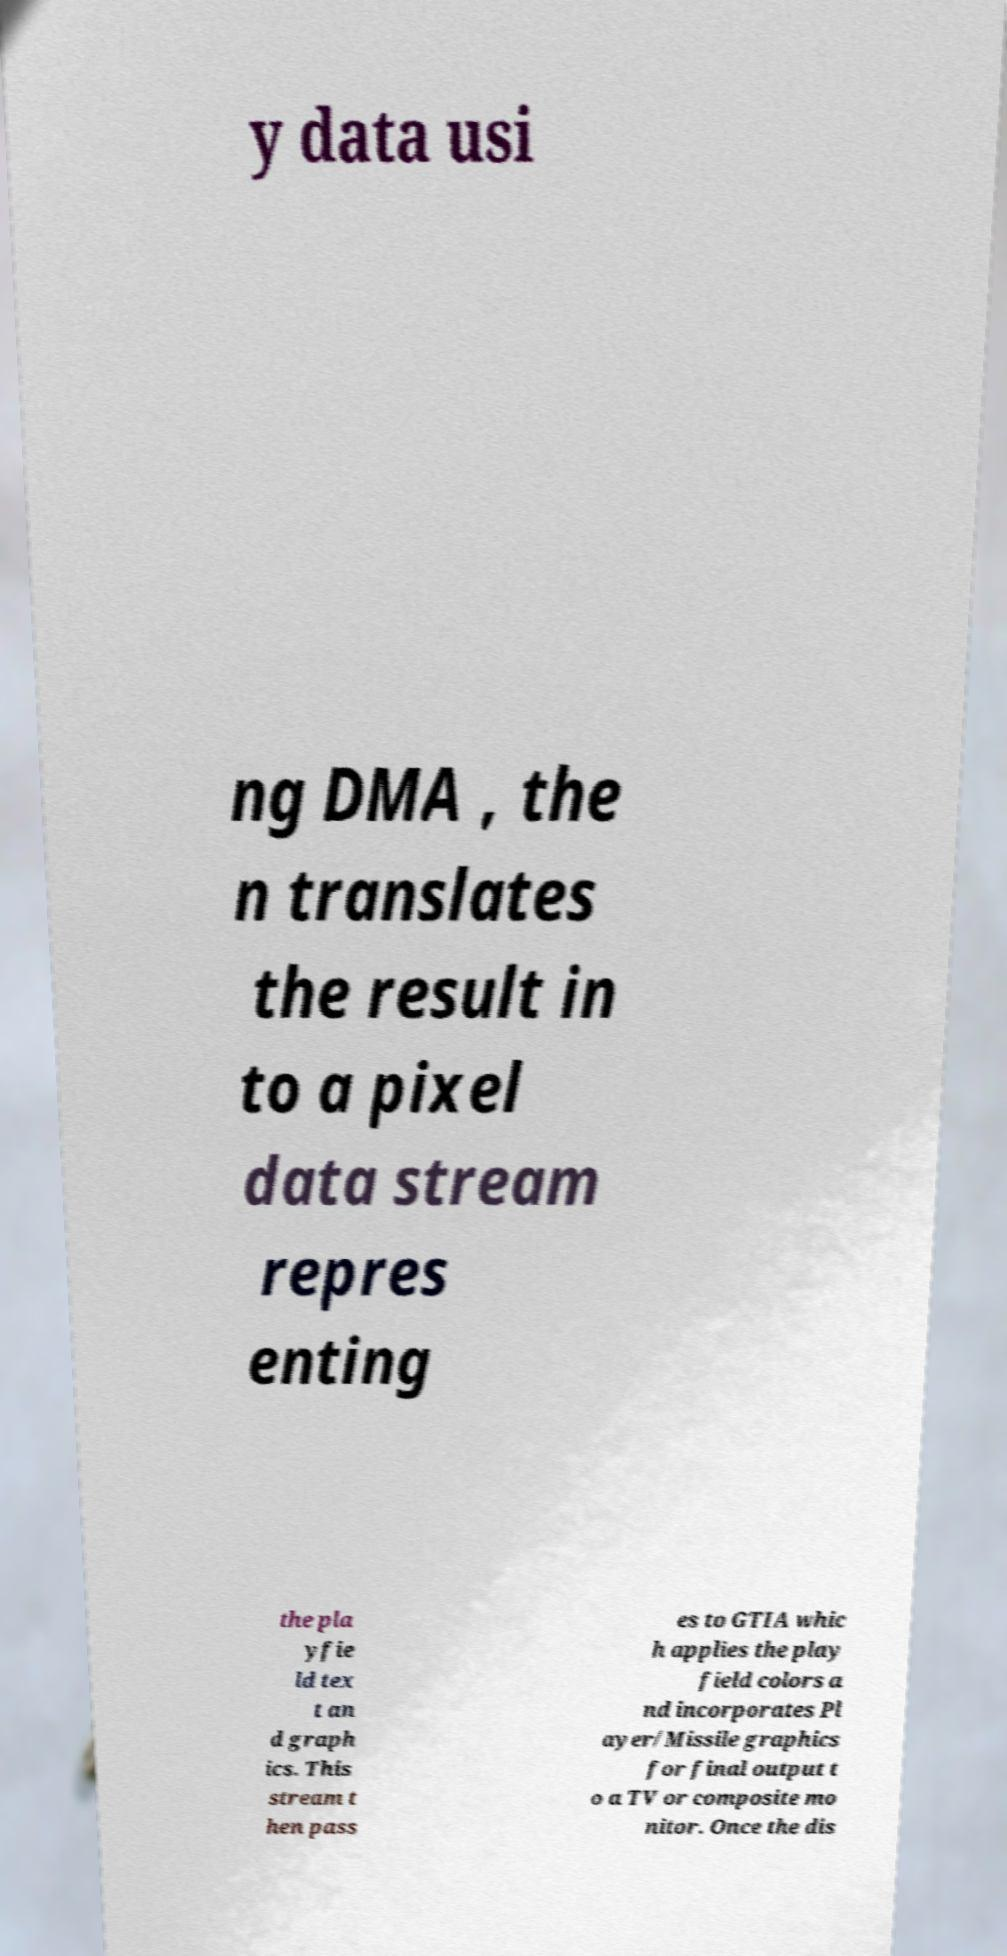For documentation purposes, I need the text within this image transcribed. Could you provide that? y data usi ng DMA , the n translates the result in to a pixel data stream repres enting the pla yfie ld tex t an d graph ics. This stream t hen pass es to GTIA whic h applies the play field colors a nd incorporates Pl ayer/Missile graphics for final output t o a TV or composite mo nitor. Once the dis 